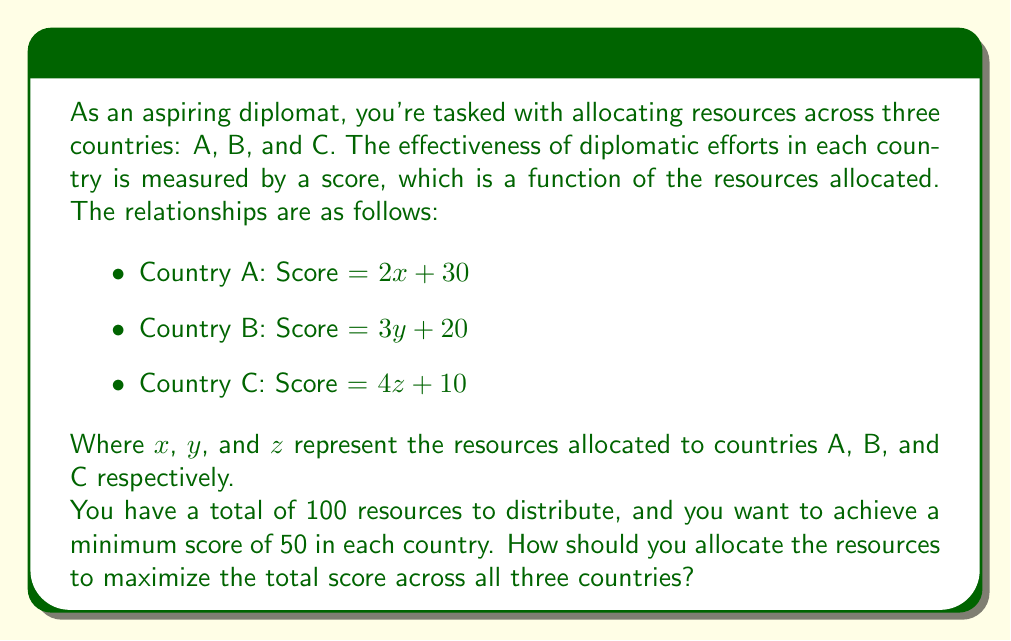Show me your answer to this math problem. Let's approach this step-by-step:

1) First, we need to set up our constraints:

   Total resources: $x + y + z = 100$
   Minimum scores: $2x + 30 \geq 50$, $3y + 20 \geq 50$, $4z + 10 \geq 50$

2) Simplify the minimum score constraints:

   $2x \geq 20$, so $x \geq 10$
   $3y \geq 30$, so $y \geq 10$
   $4z \geq 40$, so $z \geq 10$

3) Our objective is to maximize the total score:

   Total Score = $(2x + 30) + (3y + 20) + (4z + 10) = 2x + 3y + 4z + 60$

4) Given the constraints and objective, we can see that to maximize the total score, we should allocate as many resources as possible to Country C (highest coefficient), then Country B, and lastly Country A.

5) Let's allocate the minimum to A and B, and the rest to C:

   $x = 10$, $y = 10$, $z = 80$

6) Check if this satisfies our constraints:

   Total resources: $10 + 10 + 80 = 100$ ✓
   Country A score: $2(10) + 30 = 50$ ✓
   Country B score: $3(10) + 20 = 50$ ✓
   Country C score: $4(80) + 10 = 330$ ✓

7) Calculate the total score:

   Total Score = $50 + 50 + 330 = 430$

This allocation maximizes the total score while meeting all constraints.
Answer: Optimal allocation: Country A: 10 resources, Country B: 10 resources, Country C: 80 resources. Maximum total score: 430. 